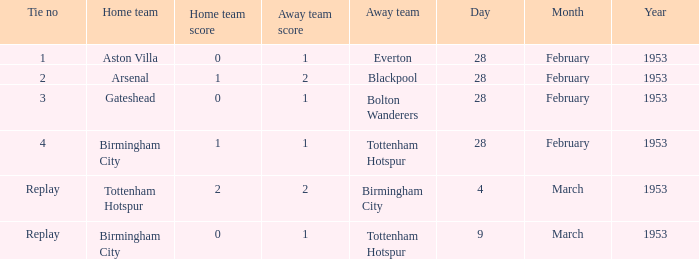Which Home team has an Away team of everton? Aston Villa. 